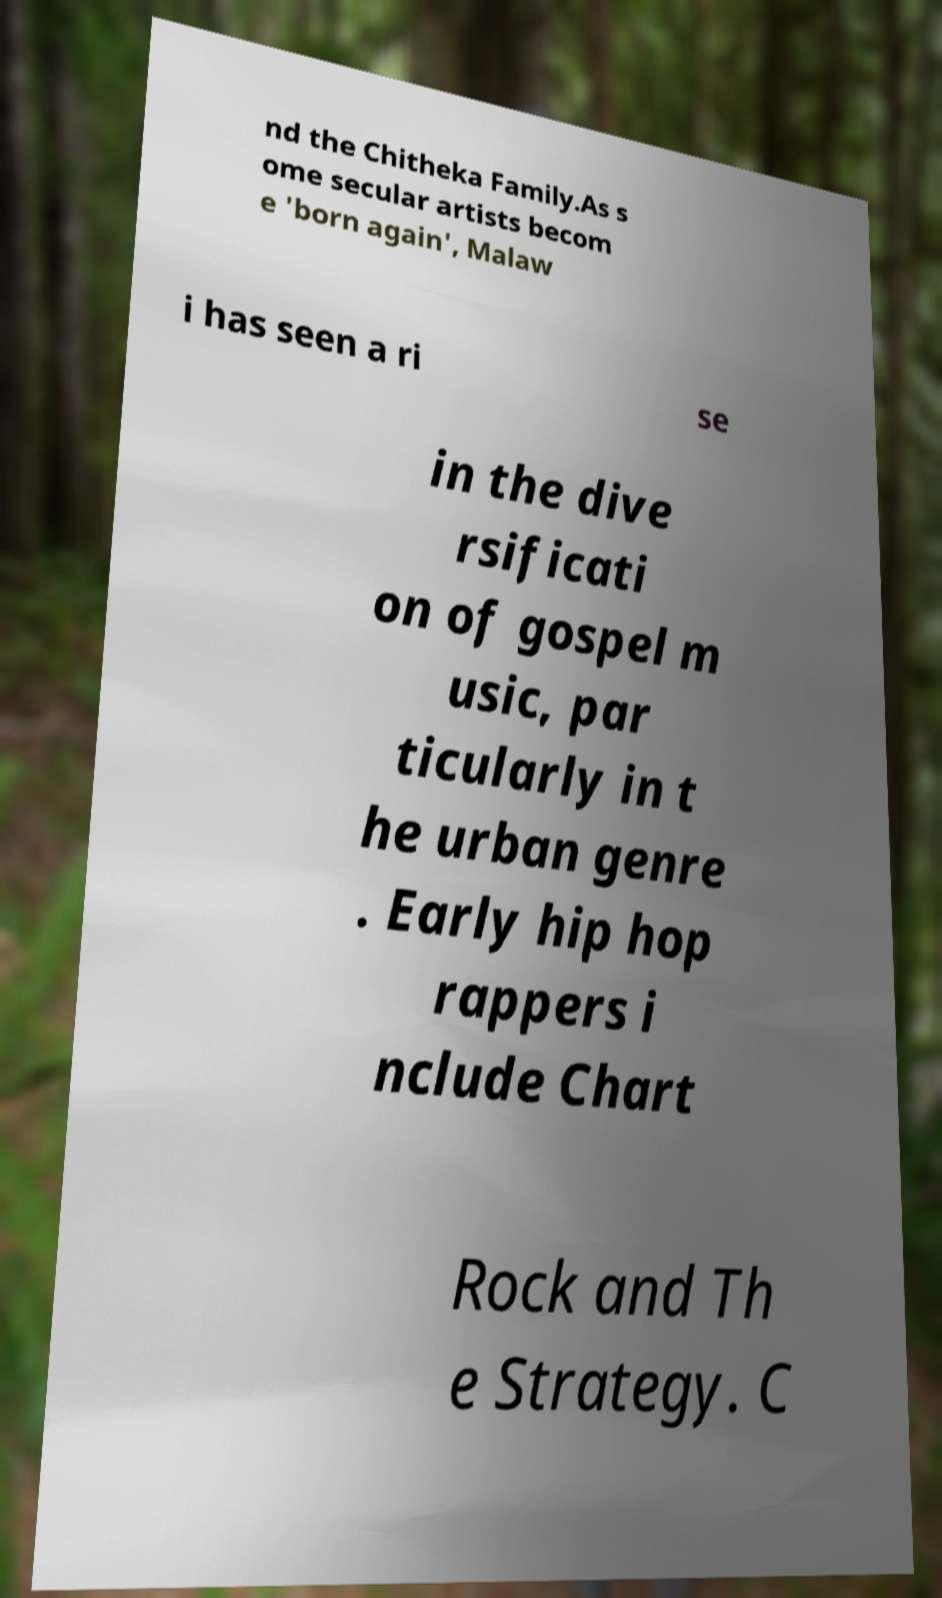Could you extract and type out the text from this image? nd the Chitheka Family.As s ome secular artists becom e 'born again', Malaw i has seen a ri se in the dive rsificati on of gospel m usic, par ticularly in t he urban genre . Early hip hop rappers i nclude Chart Rock and Th e Strategy. C 